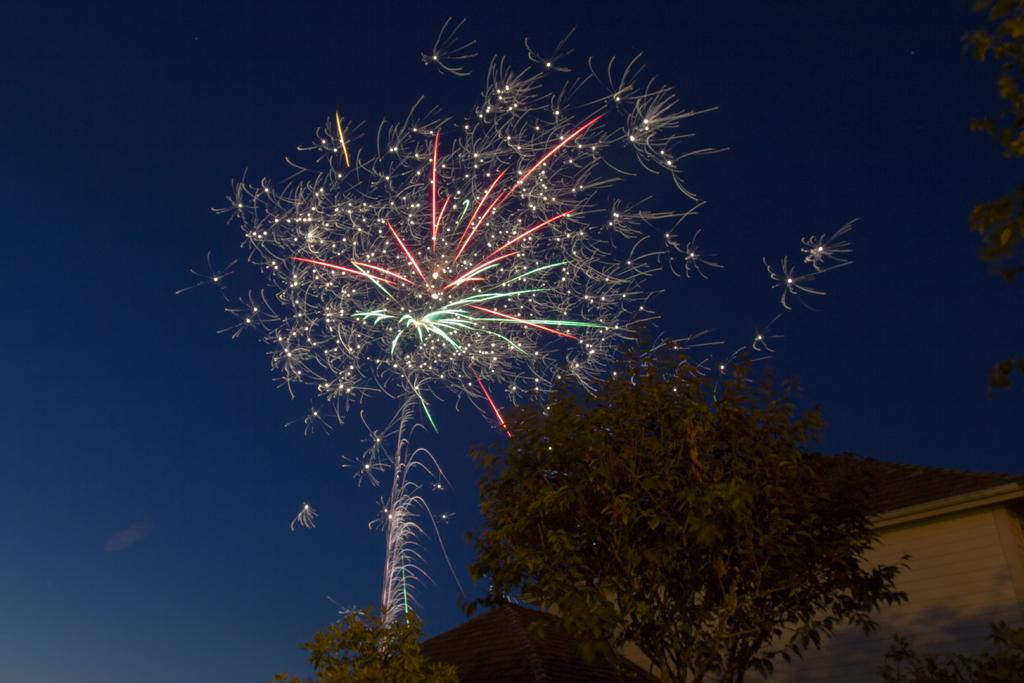What type of natural vegetation can be seen in the image? There are trees in the image. What type of man-made structures are present in the image? There are houses in the image. What additional visual effect can be observed in the image? There are sparkles visible in the image. What color is the sky in the image? The sky is blue in the image. How many beds are visible in the image? There are no beds present in the image. What role does the grandfather play in the image? There is no grandfather present in the image. 